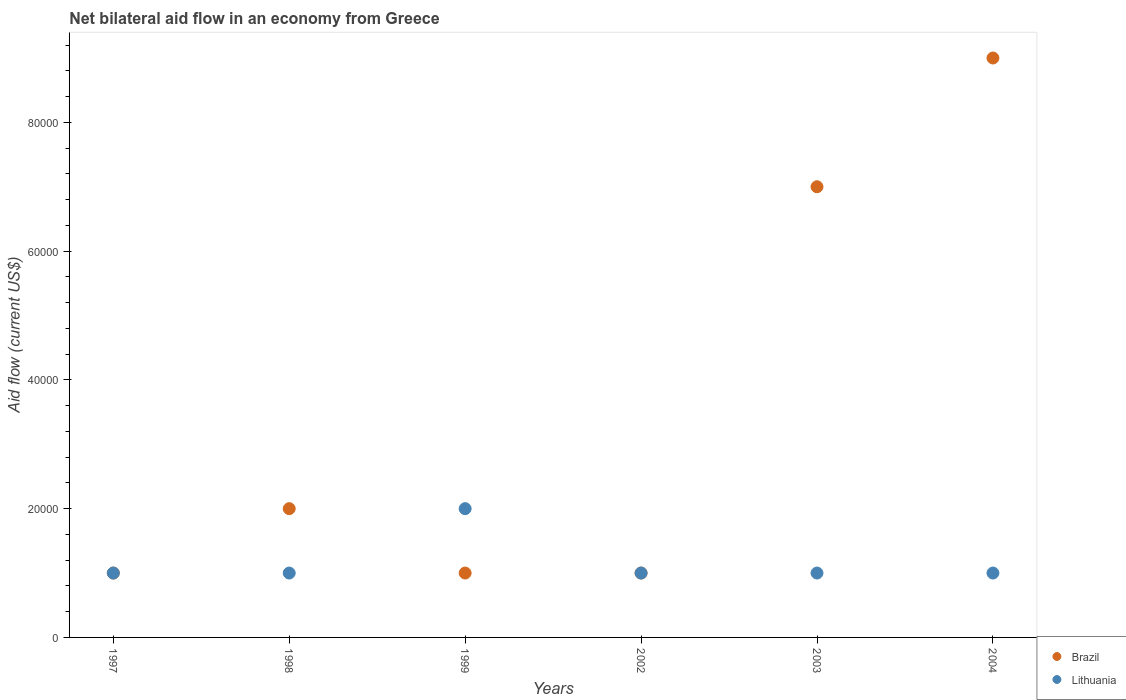Across all years, what is the maximum net bilateral aid flow in Lithuania?
Ensure brevity in your answer.  2.00e+04. In which year was the net bilateral aid flow in Lithuania maximum?
Your answer should be very brief. 1999. In which year was the net bilateral aid flow in Brazil minimum?
Provide a short and direct response. 1997. What is the total net bilateral aid flow in Brazil in the graph?
Offer a terse response. 2.10e+05. What is the average net bilateral aid flow in Lithuania per year?
Your answer should be compact. 1.17e+04. Is the net bilateral aid flow in Brazil in 1998 less than that in 2002?
Provide a short and direct response. No. Is the difference between the net bilateral aid flow in Lithuania in 2002 and 2004 greater than the difference between the net bilateral aid flow in Brazil in 2002 and 2004?
Ensure brevity in your answer.  Yes. Is the sum of the net bilateral aid flow in Brazil in 2003 and 2004 greater than the maximum net bilateral aid flow in Lithuania across all years?
Your answer should be very brief. Yes. Does the net bilateral aid flow in Lithuania monotonically increase over the years?
Provide a succinct answer. No. Is the net bilateral aid flow in Lithuania strictly greater than the net bilateral aid flow in Brazil over the years?
Keep it short and to the point. No. Is the net bilateral aid flow in Brazil strictly less than the net bilateral aid flow in Lithuania over the years?
Offer a very short reply. No. How many dotlines are there?
Offer a terse response. 2. Are the values on the major ticks of Y-axis written in scientific E-notation?
Provide a short and direct response. No. Does the graph contain grids?
Your answer should be compact. No. What is the title of the graph?
Ensure brevity in your answer.  Net bilateral aid flow in an economy from Greece. Does "Ukraine" appear as one of the legend labels in the graph?
Keep it short and to the point. No. What is the Aid flow (current US$) of Lithuania in 1997?
Keep it short and to the point. 10000. What is the Aid flow (current US$) of Lithuania in 1998?
Offer a terse response. 10000. What is the Aid flow (current US$) of Brazil in 2002?
Give a very brief answer. 10000. What is the Aid flow (current US$) in Lithuania in 2002?
Ensure brevity in your answer.  10000. What is the Aid flow (current US$) of Brazil in 2003?
Offer a very short reply. 7.00e+04. What is the Aid flow (current US$) of Brazil in 2004?
Make the answer very short. 9.00e+04. Across all years, what is the minimum Aid flow (current US$) of Brazil?
Make the answer very short. 10000. Across all years, what is the minimum Aid flow (current US$) of Lithuania?
Your answer should be very brief. 10000. What is the total Aid flow (current US$) in Brazil in the graph?
Provide a succinct answer. 2.10e+05. What is the total Aid flow (current US$) of Lithuania in the graph?
Make the answer very short. 7.00e+04. What is the difference between the Aid flow (current US$) of Brazil in 1997 and that in 1998?
Ensure brevity in your answer.  -10000. What is the difference between the Aid flow (current US$) of Lithuania in 1997 and that in 1999?
Make the answer very short. -10000. What is the difference between the Aid flow (current US$) in Brazil in 1997 and that in 2002?
Ensure brevity in your answer.  0. What is the difference between the Aid flow (current US$) in Lithuania in 1997 and that in 2004?
Provide a short and direct response. 0. What is the difference between the Aid flow (current US$) in Brazil in 1998 and that in 1999?
Give a very brief answer. 10000. What is the difference between the Aid flow (current US$) in Brazil in 1998 and that in 2002?
Your response must be concise. 10000. What is the difference between the Aid flow (current US$) in Lithuania in 1998 and that in 2004?
Keep it short and to the point. 0. What is the difference between the Aid flow (current US$) in Lithuania in 1999 and that in 2003?
Make the answer very short. 10000. What is the difference between the Aid flow (current US$) of Brazil in 1999 and that in 2004?
Offer a terse response. -8.00e+04. What is the difference between the Aid flow (current US$) of Brazil in 2002 and that in 2003?
Give a very brief answer. -6.00e+04. What is the difference between the Aid flow (current US$) in Lithuania in 2003 and that in 2004?
Keep it short and to the point. 0. What is the difference between the Aid flow (current US$) of Brazil in 1997 and the Aid flow (current US$) of Lithuania in 1998?
Provide a short and direct response. 0. What is the difference between the Aid flow (current US$) of Brazil in 1997 and the Aid flow (current US$) of Lithuania in 1999?
Offer a very short reply. -10000. What is the difference between the Aid flow (current US$) of Brazil in 1998 and the Aid flow (current US$) of Lithuania in 1999?
Ensure brevity in your answer.  0. What is the difference between the Aid flow (current US$) in Brazil in 1999 and the Aid flow (current US$) in Lithuania in 2003?
Provide a succinct answer. 0. What is the difference between the Aid flow (current US$) in Brazil in 2003 and the Aid flow (current US$) in Lithuania in 2004?
Give a very brief answer. 6.00e+04. What is the average Aid flow (current US$) in Brazil per year?
Offer a very short reply. 3.50e+04. What is the average Aid flow (current US$) of Lithuania per year?
Offer a very short reply. 1.17e+04. In the year 1997, what is the difference between the Aid flow (current US$) of Brazil and Aid flow (current US$) of Lithuania?
Your answer should be compact. 0. In the year 1998, what is the difference between the Aid flow (current US$) of Brazil and Aid flow (current US$) of Lithuania?
Make the answer very short. 10000. In the year 2002, what is the difference between the Aid flow (current US$) in Brazil and Aid flow (current US$) in Lithuania?
Ensure brevity in your answer.  0. In the year 2004, what is the difference between the Aid flow (current US$) in Brazil and Aid flow (current US$) in Lithuania?
Offer a terse response. 8.00e+04. What is the ratio of the Aid flow (current US$) in Brazil in 1997 to that in 1998?
Keep it short and to the point. 0.5. What is the ratio of the Aid flow (current US$) in Lithuania in 1997 to that in 1999?
Your answer should be very brief. 0.5. What is the ratio of the Aid flow (current US$) in Brazil in 1997 to that in 2003?
Your answer should be very brief. 0.14. What is the ratio of the Aid flow (current US$) in Lithuania in 1997 to that in 2003?
Offer a very short reply. 1. What is the ratio of the Aid flow (current US$) of Brazil in 1998 to that in 1999?
Make the answer very short. 2. What is the ratio of the Aid flow (current US$) of Lithuania in 1998 to that in 1999?
Your response must be concise. 0.5. What is the ratio of the Aid flow (current US$) of Lithuania in 1998 to that in 2002?
Your answer should be compact. 1. What is the ratio of the Aid flow (current US$) of Brazil in 1998 to that in 2003?
Your answer should be compact. 0.29. What is the ratio of the Aid flow (current US$) in Lithuania in 1998 to that in 2003?
Make the answer very short. 1. What is the ratio of the Aid flow (current US$) in Brazil in 1998 to that in 2004?
Your answer should be very brief. 0.22. What is the ratio of the Aid flow (current US$) in Brazil in 1999 to that in 2003?
Keep it short and to the point. 0.14. What is the ratio of the Aid flow (current US$) in Lithuania in 1999 to that in 2003?
Ensure brevity in your answer.  2. What is the ratio of the Aid flow (current US$) of Brazil in 2002 to that in 2003?
Offer a very short reply. 0.14. What is the ratio of the Aid flow (current US$) in Brazil in 2002 to that in 2004?
Make the answer very short. 0.11. What is the ratio of the Aid flow (current US$) in Lithuania in 2002 to that in 2004?
Provide a short and direct response. 1. What is the ratio of the Aid flow (current US$) of Lithuania in 2003 to that in 2004?
Keep it short and to the point. 1. What is the difference between the highest and the second highest Aid flow (current US$) in Brazil?
Ensure brevity in your answer.  2.00e+04. What is the difference between the highest and the lowest Aid flow (current US$) of Lithuania?
Your answer should be very brief. 10000. 